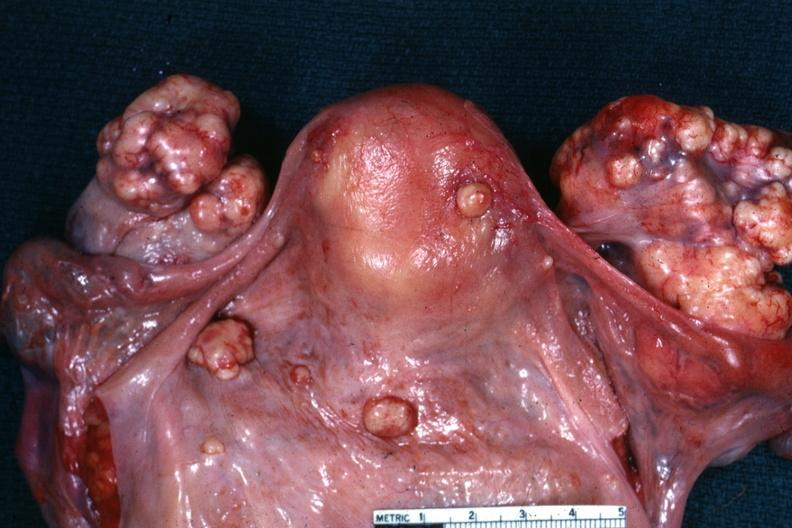s ovary present?
Answer the question using a single word or phrase. Yes 